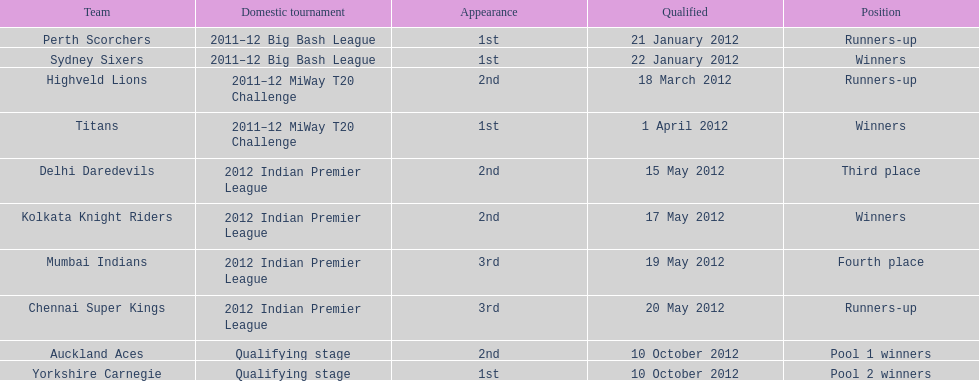Did the titans or the daredevils winners? Titans. 